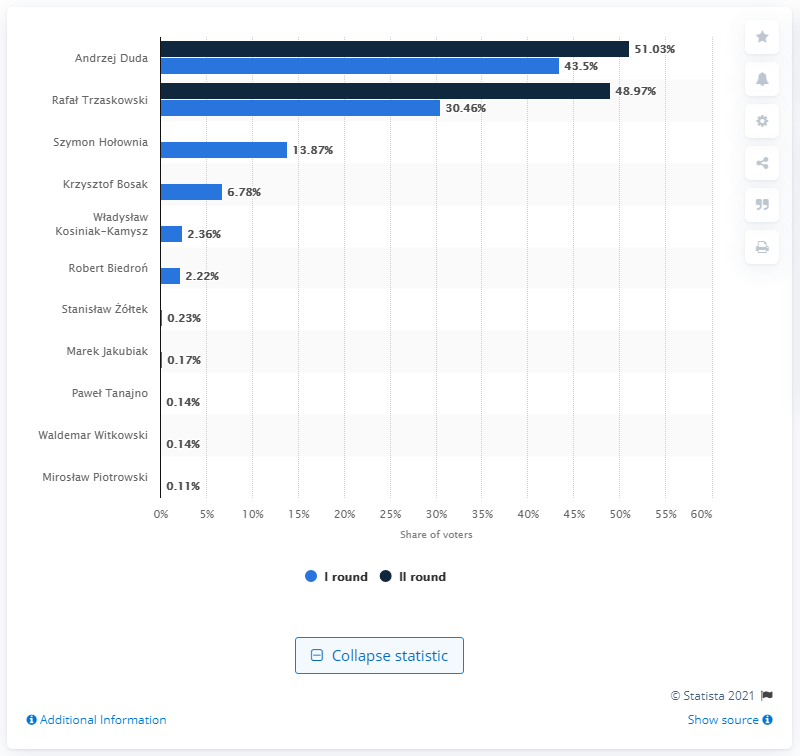Indicate a few pertinent items in this graphic. The second round of elections resulted in Andrzej Duda receiving 51.03% of the votes. 